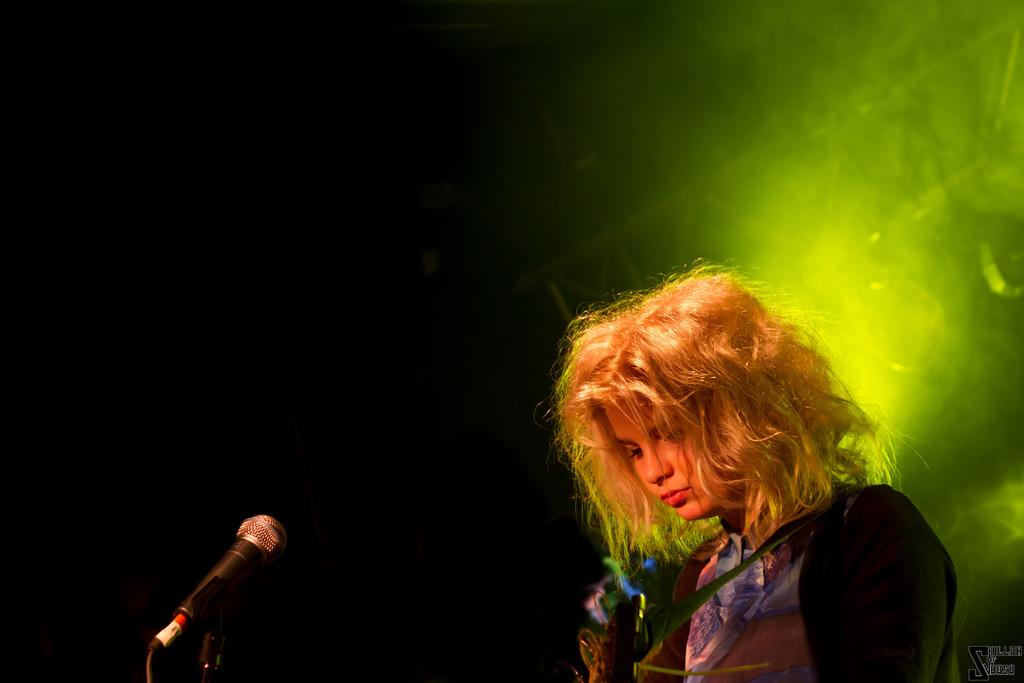What is the main subject on the right side of the image? There is a girl standing on the right side of the image. What is the girl wearing in the image? The girl is wearing a blue dress in the image. What object is placed before the girl? There is a mic placed before the girl in the image. What can be seen in the background of the image? There is a light in the background of the image. What type of story is the girl telling near the hydrant in the image? There is no hydrant present in the image, and the girl is not telling a story. 